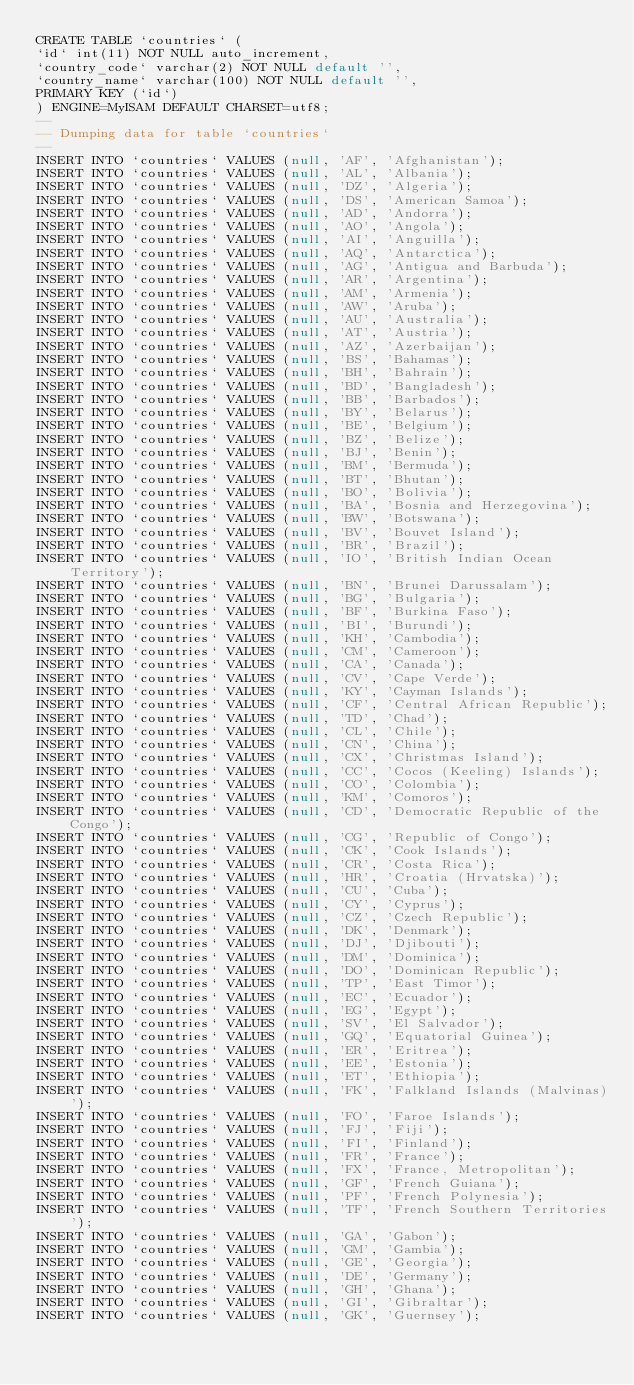<code> <loc_0><loc_0><loc_500><loc_500><_SQL_>CREATE TABLE `countries` (
`id` int(11) NOT NULL auto_increment,
`country_code` varchar(2) NOT NULL default '',
`country_name` varchar(100) NOT NULL default '',
PRIMARY KEY (`id`)
) ENGINE=MyISAM DEFAULT CHARSET=utf8;
-- 
-- Dumping data for table `countries`
-- 
INSERT INTO `countries` VALUES (null, 'AF', 'Afghanistan');
INSERT INTO `countries` VALUES (null, 'AL', 'Albania');
INSERT INTO `countries` VALUES (null, 'DZ', 'Algeria');
INSERT INTO `countries` VALUES (null, 'DS', 'American Samoa');
INSERT INTO `countries` VALUES (null, 'AD', 'Andorra');
INSERT INTO `countries` VALUES (null, 'AO', 'Angola');
INSERT INTO `countries` VALUES (null, 'AI', 'Anguilla');
INSERT INTO `countries` VALUES (null, 'AQ', 'Antarctica');
INSERT INTO `countries` VALUES (null, 'AG', 'Antigua and Barbuda');
INSERT INTO `countries` VALUES (null, 'AR', 'Argentina');
INSERT INTO `countries` VALUES (null, 'AM', 'Armenia');
INSERT INTO `countries` VALUES (null, 'AW', 'Aruba');
INSERT INTO `countries` VALUES (null, 'AU', 'Australia');
INSERT INTO `countries` VALUES (null, 'AT', 'Austria');
INSERT INTO `countries` VALUES (null, 'AZ', 'Azerbaijan');
INSERT INTO `countries` VALUES (null, 'BS', 'Bahamas');
INSERT INTO `countries` VALUES (null, 'BH', 'Bahrain');
INSERT INTO `countries` VALUES (null, 'BD', 'Bangladesh');
INSERT INTO `countries` VALUES (null, 'BB', 'Barbados');
INSERT INTO `countries` VALUES (null, 'BY', 'Belarus');
INSERT INTO `countries` VALUES (null, 'BE', 'Belgium');
INSERT INTO `countries` VALUES (null, 'BZ', 'Belize');
INSERT INTO `countries` VALUES (null, 'BJ', 'Benin');
INSERT INTO `countries` VALUES (null, 'BM', 'Bermuda');
INSERT INTO `countries` VALUES (null, 'BT', 'Bhutan');
INSERT INTO `countries` VALUES (null, 'BO', 'Bolivia');
INSERT INTO `countries` VALUES (null, 'BA', 'Bosnia and Herzegovina');
INSERT INTO `countries` VALUES (null, 'BW', 'Botswana');
INSERT INTO `countries` VALUES (null, 'BV', 'Bouvet Island');
INSERT INTO `countries` VALUES (null, 'BR', 'Brazil');
INSERT INTO `countries` VALUES (null, 'IO', 'British Indian Ocean Territory');
INSERT INTO `countries` VALUES (null, 'BN', 'Brunei Darussalam');
INSERT INTO `countries` VALUES (null, 'BG', 'Bulgaria');
INSERT INTO `countries` VALUES (null, 'BF', 'Burkina Faso');
INSERT INTO `countries` VALUES (null, 'BI', 'Burundi');
INSERT INTO `countries` VALUES (null, 'KH', 'Cambodia');
INSERT INTO `countries` VALUES (null, 'CM', 'Cameroon');
INSERT INTO `countries` VALUES (null, 'CA', 'Canada');
INSERT INTO `countries` VALUES (null, 'CV', 'Cape Verde');
INSERT INTO `countries` VALUES (null, 'KY', 'Cayman Islands');
INSERT INTO `countries` VALUES (null, 'CF', 'Central African Republic');
INSERT INTO `countries` VALUES (null, 'TD', 'Chad');
INSERT INTO `countries` VALUES (null, 'CL', 'Chile');
INSERT INTO `countries` VALUES (null, 'CN', 'China');
INSERT INTO `countries` VALUES (null, 'CX', 'Christmas Island');
INSERT INTO `countries` VALUES (null, 'CC', 'Cocos (Keeling) Islands');
INSERT INTO `countries` VALUES (null, 'CO', 'Colombia');
INSERT INTO `countries` VALUES (null, 'KM', 'Comoros');
INSERT INTO `countries` VALUES (null, 'CD', 'Democratic Republic of the Congo');
INSERT INTO `countries` VALUES (null, 'CG', 'Republic of Congo');
INSERT INTO `countries` VALUES (null, 'CK', 'Cook Islands');
INSERT INTO `countries` VALUES (null, 'CR', 'Costa Rica');
INSERT INTO `countries` VALUES (null, 'HR', 'Croatia (Hrvatska)');
INSERT INTO `countries` VALUES (null, 'CU', 'Cuba');
INSERT INTO `countries` VALUES (null, 'CY', 'Cyprus');
INSERT INTO `countries` VALUES (null, 'CZ', 'Czech Republic');
INSERT INTO `countries` VALUES (null, 'DK', 'Denmark');
INSERT INTO `countries` VALUES (null, 'DJ', 'Djibouti');
INSERT INTO `countries` VALUES (null, 'DM', 'Dominica');
INSERT INTO `countries` VALUES (null, 'DO', 'Dominican Republic');
INSERT INTO `countries` VALUES (null, 'TP', 'East Timor');
INSERT INTO `countries` VALUES (null, 'EC', 'Ecuador');
INSERT INTO `countries` VALUES (null, 'EG', 'Egypt');
INSERT INTO `countries` VALUES (null, 'SV', 'El Salvador');
INSERT INTO `countries` VALUES (null, 'GQ', 'Equatorial Guinea');
INSERT INTO `countries` VALUES (null, 'ER', 'Eritrea');
INSERT INTO `countries` VALUES (null, 'EE', 'Estonia');
INSERT INTO `countries` VALUES (null, 'ET', 'Ethiopia');
INSERT INTO `countries` VALUES (null, 'FK', 'Falkland Islands (Malvinas)');
INSERT INTO `countries` VALUES (null, 'FO', 'Faroe Islands');
INSERT INTO `countries` VALUES (null, 'FJ', 'Fiji');
INSERT INTO `countries` VALUES (null, 'FI', 'Finland');
INSERT INTO `countries` VALUES (null, 'FR', 'France');
INSERT INTO `countries` VALUES (null, 'FX', 'France, Metropolitan');
INSERT INTO `countries` VALUES (null, 'GF', 'French Guiana');
INSERT INTO `countries` VALUES (null, 'PF', 'French Polynesia');
INSERT INTO `countries` VALUES (null, 'TF', 'French Southern Territories');
INSERT INTO `countries` VALUES (null, 'GA', 'Gabon');
INSERT INTO `countries` VALUES (null, 'GM', 'Gambia');
INSERT INTO `countries` VALUES (null, 'GE', 'Georgia');
INSERT INTO `countries` VALUES (null, 'DE', 'Germany');
INSERT INTO `countries` VALUES (null, 'GH', 'Ghana');
INSERT INTO `countries` VALUES (null, 'GI', 'Gibraltar');
INSERT INTO `countries` VALUES (null, 'GK', 'Guernsey');</code> 